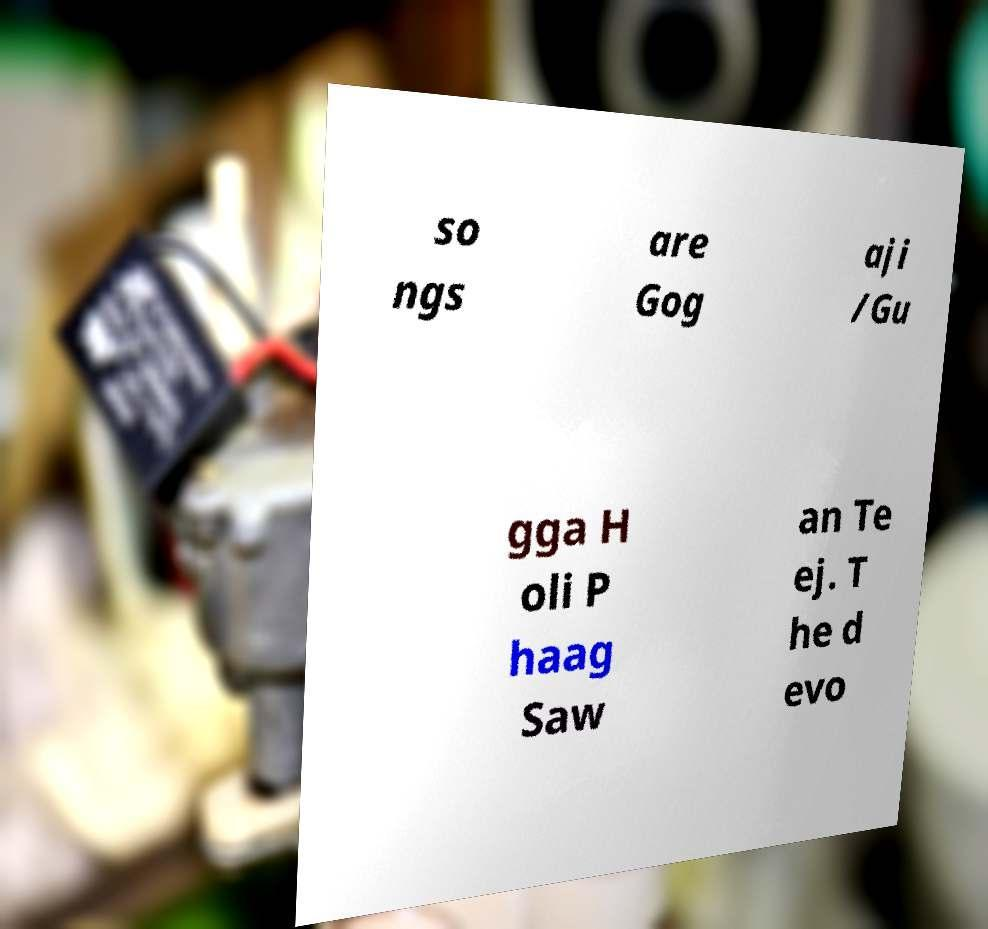Can you accurately transcribe the text from the provided image for me? so ngs are Gog aji /Gu gga H oli P haag Saw an Te ej. T he d evo 